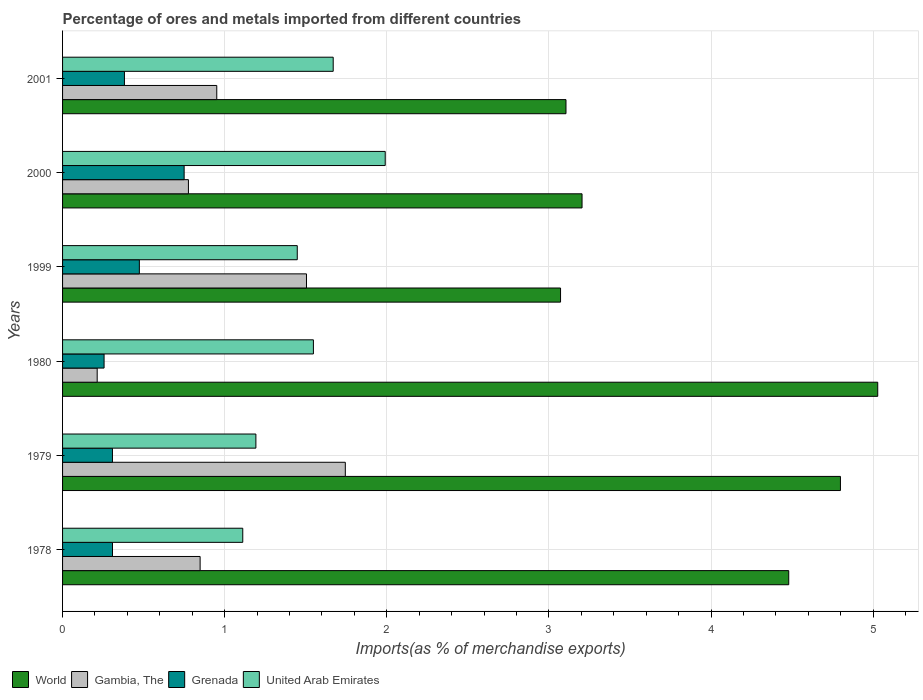How many groups of bars are there?
Provide a short and direct response. 6. Are the number of bars on each tick of the Y-axis equal?
Make the answer very short. Yes. How many bars are there on the 2nd tick from the top?
Offer a very short reply. 4. How many bars are there on the 6th tick from the bottom?
Your response must be concise. 4. What is the percentage of imports to different countries in World in 2000?
Provide a short and direct response. 3.2. Across all years, what is the maximum percentage of imports to different countries in Grenada?
Your answer should be very brief. 0.75. Across all years, what is the minimum percentage of imports to different countries in World?
Your answer should be compact. 3.07. In which year was the percentage of imports to different countries in World maximum?
Your response must be concise. 1980. What is the total percentage of imports to different countries in World in the graph?
Give a very brief answer. 23.69. What is the difference between the percentage of imports to different countries in World in 1978 and that in 2001?
Offer a very short reply. 1.37. What is the difference between the percentage of imports to different countries in World in 1978 and the percentage of imports to different countries in Grenada in 2000?
Provide a succinct answer. 3.73. What is the average percentage of imports to different countries in World per year?
Your answer should be compact. 3.95. In the year 1999, what is the difference between the percentage of imports to different countries in United Arab Emirates and percentage of imports to different countries in Grenada?
Your answer should be very brief. 0.97. What is the ratio of the percentage of imports to different countries in World in 1978 to that in 2000?
Offer a terse response. 1.4. Is the difference between the percentage of imports to different countries in United Arab Emirates in 1979 and 2000 greater than the difference between the percentage of imports to different countries in Grenada in 1979 and 2000?
Provide a succinct answer. No. What is the difference between the highest and the second highest percentage of imports to different countries in Gambia, The?
Provide a succinct answer. 0.24. What is the difference between the highest and the lowest percentage of imports to different countries in World?
Keep it short and to the point. 1.96. What does the 3rd bar from the top in 1999 represents?
Provide a short and direct response. Gambia, The. What does the 4th bar from the bottom in 2000 represents?
Provide a succinct answer. United Arab Emirates. Is it the case that in every year, the sum of the percentage of imports to different countries in Gambia, The and percentage of imports to different countries in Grenada is greater than the percentage of imports to different countries in World?
Make the answer very short. No. How many bars are there?
Give a very brief answer. 24. Are all the bars in the graph horizontal?
Ensure brevity in your answer.  Yes. How many years are there in the graph?
Keep it short and to the point. 6. Are the values on the major ticks of X-axis written in scientific E-notation?
Offer a very short reply. No. Does the graph contain grids?
Keep it short and to the point. Yes. Where does the legend appear in the graph?
Keep it short and to the point. Bottom left. How many legend labels are there?
Give a very brief answer. 4. What is the title of the graph?
Ensure brevity in your answer.  Percentage of ores and metals imported from different countries. What is the label or title of the X-axis?
Provide a succinct answer. Imports(as % of merchandise exports). What is the label or title of the Y-axis?
Make the answer very short. Years. What is the Imports(as % of merchandise exports) of World in 1978?
Your response must be concise. 4.48. What is the Imports(as % of merchandise exports) of Gambia, The in 1978?
Ensure brevity in your answer.  0.85. What is the Imports(as % of merchandise exports) of Grenada in 1978?
Give a very brief answer. 0.31. What is the Imports(as % of merchandise exports) in United Arab Emirates in 1978?
Your response must be concise. 1.11. What is the Imports(as % of merchandise exports) of World in 1979?
Your answer should be very brief. 4.8. What is the Imports(as % of merchandise exports) of Gambia, The in 1979?
Provide a succinct answer. 1.74. What is the Imports(as % of merchandise exports) of Grenada in 1979?
Make the answer very short. 0.31. What is the Imports(as % of merchandise exports) of United Arab Emirates in 1979?
Offer a terse response. 1.19. What is the Imports(as % of merchandise exports) in World in 1980?
Provide a succinct answer. 5.03. What is the Imports(as % of merchandise exports) in Gambia, The in 1980?
Your response must be concise. 0.21. What is the Imports(as % of merchandise exports) in Grenada in 1980?
Make the answer very short. 0.26. What is the Imports(as % of merchandise exports) of United Arab Emirates in 1980?
Your response must be concise. 1.55. What is the Imports(as % of merchandise exports) of World in 1999?
Give a very brief answer. 3.07. What is the Imports(as % of merchandise exports) in Gambia, The in 1999?
Make the answer very short. 1.5. What is the Imports(as % of merchandise exports) of Grenada in 1999?
Make the answer very short. 0.47. What is the Imports(as % of merchandise exports) in United Arab Emirates in 1999?
Provide a succinct answer. 1.45. What is the Imports(as % of merchandise exports) in World in 2000?
Provide a succinct answer. 3.2. What is the Imports(as % of merchandise exports) of Gambia, The in 2000?
Ensure brevity in your answer.  0.78. What is the Imports(as % of merchandise exports) of Grenada in 2000?
Provide a short and direct response. 0.75. What is the Imports(as % of merchandise exports) of United Arab Emirates in 2000?
Make the answer very short. 1.99. What is the Imports(as % of merchandise exports) of World in 2001?
Ensure brevity in your answer.  3.11. What is the Imports(as % of merchandise exports) of Gambia, The in 2001?
Your answer should be very brief. 0.95. What is the Imports(as % of merchandise exports) of Grenada in 2001?
Offer a very short reply. 0.38. What is the Imports(as % of merchandise exports) of United Arab Emirates in 2001?
Provide a succinct answer. 1.67. Across all years, what is the maximum Imports(as % of merchandise exports) of World?
Your answer should be very brief. 5.03. Across all years, what is the maximum Imports(as % of merchandise exports) of Gambia, The?
Provide a short and direct response. 1.74. Across all years, what is the maximum Imports(as % of merchandise exports) of Grenada?
Give a very brief answer. 0.75. Across all years, what is the maximum Imports(as % of merchandise exports) in United Arab Emirates?
Ensure brevity in your answer.  1.99. Across all years, what is the minimum Imports(as % of merchandise exports) in World?
Make the answer very short. 3.07. Across all years, what is the minimum Imports(as % of merchandise exports) in Gambia, The?
Ensure brevity in your answer.  0.21. Across all years, what is the minimum Imports(as % of merchandise exports) in Grenada?
Give a very brief answer. 0.26. Across all years, what is the minimum Imports(as % of merchandise exports) of United Arab Emirates?
Keep it short and to the point. 1.11. What is the total Imports(as % of merchandise exports) of World in the graph?
Offer a very short reply. 23.69. What is the total Imports(as % of merchandise exports) of Gambia, The in the graph?
Your response must be concise. 6.04. What is the total Imports(as % of merchandise exports) of Grenada in the graph?
Ensure brevity in your answer.  2.48. What is the total Imports(as % of merchandise exports) of United Arab Emirates in the graph?
Your answer should be very brief. 8.96. What is the difference between the Imports(as % of merchandise exports) in World in 1978 and that in 1979?
Offer a very short reply. -0.32. What is the difference between the Imports(as % of merchandise exports) of Gambia, The in 1978 and that in 1979?
Offer a terse response. -0.9. What is the difference between the Imports(as % of merchandise exports) in United Arab Emirates in 1978 and that in 1979?
Ensure brevity in your answer.  -0.08. What is the difference between the Imports(as % of merchandise exports) of World in 1978 and that in 1980?
Offer a terse response. -0.55. What is the difference between the Imports(as % of merchandise exports) in Gambia, The in 1978 and that in 1980?
Your response must be concise. 0.64. What is the difference between the Imports(as % of merchandise exports) of Grenada in 1978 and that in 1980?
Your answer should be very brief. 0.05. What is the difference between the Imports(as % of merchandise exports) in United Arab Emirates in 1978 and that in 1980?
Your answer should be compact. -0.44. What is the difference between the Imports(as % of merchandise exports) of World in 1978 and that in 1999?
Your answer should be very brief. 1.41. What is the difference between the Imports(as % of merchandise exports) in Gambia, The in 1978 and that in 1999?
Offer a very short reply. -0.66. What is the difference between the Imports(as % of merchandise exports) of Grenada in 1978 and that in 1999?
Your response must be concise. -0.17. What is the difference between the Imports(as % of merchandise exports) of United Arab Emirates in 1978 and that in 1999?
Offer a terse response. -0.34. What is the difference between the Imports(as % of merchandise exports) of World in 1978 and that in 2000?
Provide a succinct answer. 1.27. What is the difference between the Imports(as % of merchandise exports) of Gambia, The in 1978 and that in 2000?
Provide a succinct answer. 0.07. What is the difference between the Imports(as % of merchandise exports) in Grenada in 1978 and that in 2000?
Your response must be concise. -0.44. What is the difference between the Imports(as % of merchandise exports) of United Arab Emirates in 1978 and that in 2000?
Give a very brief answer. -0.88. What is the difference between the Imports(as % of merchandise exports) of World in 1978 and that in 2001?
Your response must be concise. 1.37. What is the difference between the Imports(as % of merchandise exports) of Gambia, The in 1978 and that in 2001?
Make the answer very short. -0.1. What is the difference between the Imports(as % of merchandise exports) of Grenada in 1978 and that in 2001?
Give a very brief answer. -0.07. What is the difference between the Imports(as % of merchandise exports) in United Arab Emirates in 1978 and that in 2001?
Your answer should be very brief. -0.56. What is the difference between the Imports(as % of merchandise exports) in World in 1979 and that in 1980?
Your answer should be very brief. -0.23. What is the difference between the Imports(as % of merchandise exports) of Gambia, The in 1979 and that in 1980?
Keep it short and to the point. 1.53. What is the difference between the Imports(as % of merchandise exports) of Grenada in 1979 and that in 1980?
Your answer should be very brief. 0.05. What is the difference between the Imports(as % of merchandise exports) of United Arab Emirates in 1979 and that in 1980?
Give a very brief answer. -0.35. What is the difference between the Imports(as % of merchandise exports) of World in 1979 and that in 1999?
Provide a short and direct response. 1.73. What is the difference between the Imports(as % of merchandise exports) of Gambia, The in 1979 and that in 1999?
Provide a succinct answer. 0.24. What is the difference between the Imports(as % of merchandise exports) in Grenada in 1979 and that in 1999?
Offer a terse response. -0.17. What is the difference between the Imports(as % of merchandise exports) of United Arab Emirates in 1979 and that in 1999?
Offer a very short reply. -0.26. What is the difference between the Imports(as % of merchandise exports) in World in 1979 and that in 2000?
Give a very brief answer. 1.59. What is the difference between the Imports(as % of merchandise exports) of Gambia, The in 1979 and that in 2000?
Provide a succinct answer. 0.97. What is the difference between the Imports(as % of merchandise exports) of Grenada in 1979 and that in 2000?
Offer a terse response. -0.44. What is the difference between the Imports(as % of merchandise exports) of United Arab Emirates in 1979 and that in 2000?
Your answer should be very brief. -0.8. What is the difference between the Imports(as % of merchandise exports) in World in 1979 and that in 2001?
Provide a short and direct response. 1.69. What is the difference between the Imports(as % of merchandise exports) of Gambia, The in 1979 and that in 2001?
Your answer should be very brief. 0.79. What is the difference between the Imports(as % of merchandise exports) of Grenada in 1979 and that in 2001?
Offer a terse response. -0.07. What is the difference between the Imports(as % of merchandise exports) in United Arab Emirates in 1979 and that in 2001?
Give a very brief answer. -0.48. What is the difference between the Imports(as % of merchandise exports) in World in 1980 and that in 1999?
Ensure brevity in your answer.  1.96. What is the difference between the Imports(as % of merchandise exports) in Gambia, The in 1980 and that in 1999?
Make the answer very short. -1.29. What is the difference between the Imports(as % of merchandise exports) in Grenada in 1980 and that in 1999?
Provide a short and direct response. -0.22. What is the difference between the Imports(as % of merchandise exports) in United Arab Emirates in 1980 and that in 1999?
Provide a succinct answer. 0.1. What is the difference between the Imports(as % of merchandise exports) in World in 1980 and that in 2000?
Your response must be concise. 1.82. What is the difference between the Imports(as % of merchandise exports) of Gambia, The in 1980 and that in 2000?
Keep it short and to the point. -0.56. What is the difference between the Imports(as % of merchandise exports) of Grenada in 1980 and that in 2000?
Keep it short and to the point. -0.49. What is the difference between the Imports(as % of merchandise exports) of United Arab Emirates in 1980 and that in 2000?
Keep it short and to the point. -0.44. What is the difference between the Imports(as % of merchandise exports) in World in 1980 and that in 2001?
Your response must be concise. 1.92. What is the difference between the Imports(as % of merchandise exports) in Gambia, The in 1980 and that in 2001?
Make the answer very short. -0.74. What is the difference between the Imports(as % of merchandise exports) in Grenada in 1980 and that in 2001?
Your response must be concise. -0.13. What is the difference between the Imports(as % of merchandise exports) of United Arab Emirates in 1980 and that in 2001?
Your answer should be compact. -0.12. What is the difference between the Imports(as % of merchandise exports) of World in 1999 and that in 2000?
Provide a succinct answer. -0.13. What is the difference between the Imports(as % of merchandise exports) in Gambia, The in 1999 and that in 2000?
Give a very brief answer. 0.73. What is the difference between the Imports(as % of merchandise exports) in Grenada in 1999 and that in 2000?
Make the answer very short. -0.28. What is the difference between the Imports(as % of merchandise exports) of United Arab Emirates in 1999 and that in 2000?
Your answer should be very brief. -0.54. What is the difference between the Imports(as % of merchandise exports) in World in 1999 and that in 2001?
Ensure brevity in your answer.  -0.03. What is the difference between the Imports(as % of merchandise exports) of Gambia, The in 1999 and that in 2001?
Provide a succinct answer. 0.55. What is the difference between the Imports(as % of merchandise exports) of Grenada in 1999 and that in 2001?
Offer a very short reply. 0.09. What is the difference between the Imports(as % of merchandise exports) in United Arab Emirates in 1999 and that in 2001?
Offer a terse response. -0.22. What is the difference between the Imports(as % of merchandise exports) in World in 2000 and that in 2001?
Your response must be concise. 0.1. What is the difference between the Imports(as % of merchandise exports) in Gambia, The in 2000 and that in 2001?
Offer a terse response. -0.17. What is the difference between the Imports(as % of merchandise exports) of Grenada in 2000 and that in 2001?
Your answer should be compact. 0.37. What is the difference between the Imports(as % of merchandise exports) in United Arab Emirates in 2000 and that in 2001?
Provide a succinct answer. 0.32. What is the difference between the Imports(as % of merchandise exports) in World in 1978 and the Imports(as % of merchandise exports) in Gambia, The in 1979?
Your answer should be very brief. 2.74. What is the difference between the Imports(as % of merchandise exports) in World in 1978 and the Imports(as % of merchandise exports) in Grenada in 1979?
Provide a succinct answer. 4.17. What is the difference between the Imports(as % of merchandise exports) of World in 1978 and the Imports(as % of merchandise exports) of United Arab Emirates in 1979?
Provide a short and direct response. 3.29. What is the difference between the Imports(as % of merchandise exports) of Gambia, The in 1978 and the Imports(as % of merchandise exports) of Grenada in 1979?
Make the answer very short. 0.54. What is the difference between the Imports(as % of merchandise exports) of Gambia, The in 1978 and the Imports(as % of merchandise exports) of United Arab Emirates in 1979?
Give a very brief answer. -0.34. What is the difference between the Imports(as % of merchandise exports) in Grenada in 1978 and the Imports(as % of merchandise exports) in United Arab Emirates in 1979?
Provide a succinct answer. -0.88. What is the difference between the Imports(as % of merchandise exports) of World in 1978 and the Imports(as % of merchandise exports) of Gambia, The in 1980?
Make the answer very short. 4.27. What is the difference between the Imports(as % of merchandise exports) of World in 1978 and the Imports(as % of merchandise exports) of Grenada in 1980?
Your response must be concise. 4.22. What is the difference between the Imports(as % of merchandise exports) in World in 1978 and the Imports(as % of merchandise exports) in United Arab Emirates in 1980?
Your response must be concise. 2.93. What is the difference between the Imports(as % of merchandise exports) in Gambia, The in 1978 and the Imports(as % of merchandise exports) in Grenada in 1980?
Your response must be concise. 0.59. What is the difference between the Imports(as % of merchandise exports) in Gambia, The in 1978 and the Imports(as % of merchandise exports) in United Arab Emirates in 1980?
Make the answer very short. -0.7. What is the difference between the Imports(as % of merchandise exports) of Grenada in 1978 and the Imports(as % of merchandise exports) of United Arab Emirates in 1980?
Your answer should be very brief. -1.24. What is the difference between the Imports(as % of merchandise exports) of World in 1978 and the Imports(as % of merchandise exports) of Gambia, The in 1999?
Provide a succinct answer. 2.97. What is the difference between the Imports(as % of merchandise exports) in World in 1978 and the Imports(as % of merchandise exports) in Grenada in 1999?
Ensure brevity in your answer.  4.01. What is the difference between the Imports(as % of merchandise exports) in World in 1978 and the Imports(as % of merchandise exports) in United Arab Emirates in 1999?
Give a very brief answer. 3.03. What is the difference between the Imports(as % of merchandise exports) of Gambia, The in 1978 and the Imports(as % of merchandise exports) of Grenada in 1999?
Your response must be concise. 0.37. What is the difference between the Imports(as % of merchandise exports) in Gambia, The in 1978 and the Imports(as % of merchandise exports) in United Arab Emirates in 1999?
Provide a succinct answer. -0.6. What is the difference between the Imports(as % of merchandise exports) in Grenada in 1978 and the Imports(as % of merchandise exports) in United Arab Emirates in 1999?
Make the answer very short. -1.14. What is the difference between the Imports(as % of merchandise exports) of World in 1978 and the Imports(as % of merchandise exports) of Gambia, The in 2000?
Make the answer very short. 3.7. What is the difference between the Imports(as % of merchandise exports) of World in 1978 and the Imports(as % of merchandise exports) of Grenada in 2000?
Keep it short and to the point. 3.73. What is the difference between the Imports(as % of merchandise exports) of World in 1978 and the Imports(as % of merchandise exports) of United Arab Emirates in 2000?
Give a very brief answer. 2.49. What is the difference between the Imports(as % of merchandise exports) of Gambia, The in 1978 and the Imports(as % of merchandise exports) of Grenada in 2000?
Your answer should be very brief. 0.1. What is the difference between the Imports(as % of merchandise exports) of Gambia, The in 1978 and the Imports(as % of merchandise exports) of United Arab Emirates in 2000?
Keep it short and to the point. -1.14. What is the difference between the Imports(as % of merchandise exports) in Grenada in 1978 and the Imports(as % of merchandise exports) in United Arab Emirates in 2000?
Provide a short and direct response. -1.68. What is the difference between the Imports(as % of merchandise exports) in World in 1978 and the Imports(as % of merchandise exports) in Gambia, The in 2001?
Provide a short and direct response. 3.53. What is the difference between the Imports(as % of merchandise exports) in World in 1978 and the Imports(as % of merchandise exports) in Grenada in 2001?
Offer a terse response. 4.1. What is the difference between the Imports(as % of merchandise exports) of World in 1978 and the Imports(as % of merchandise exports) of United Arab Emirates in 2001?
Keep it short and to the point. 2.81. What is the difference between the Imports(as % of merchandise exports) in Gambia, The in 1978 and the Imports(as % of merchandise exports) in Grenada in 2001?
Your response must be concise. 0.47. What is the difference between the Imports(as % of merchandise exports) in Gambia, The in 1978 and the Imports(as % of merchandise exports) in United Arab Emirates in 2001?
Ensure brevity in your answer.  -0.82. What is the difference between the Imports(as % of merchandise exports) of Grenada in 1978 and the Imports(as % of merchandise exports) of United Arab Emirates in 2001?
Your answer should be very brief. -1.36. What is the difference between the Imports(as % of merchandise exports) in World in 1979 and the Imports(as % of merchandise exports) in Gambia, The in 1980?
Keep it short and to the point. 4.58. What is the difference between the Imports(as % of merchandise exports) in World in 1979 and the Imports(as % of merchandise exports) in Grenada in 1980?
Provide a succinct answer. 4.54. What is the difference between the Imports(as % of merchandise exports) of World in 1979 and the Imports(as % of merchandise exports) of United Arab Emirates in 1980?
Make the answer very short. 3.25. What is the difference between the Imports(as % of merchandise exports) of Gambia, The in 1979 and the Imports(as % of merchandise exports) of Grenada in 1980?
Your answer should be compact. 1.49. What is the difference between the Imports(as % of merchandise exports) in Gambia, The in 1979 and the Imports(as % of merchandise exports) in United Arab Emirates in 1980?
Provide a succinct answer. 0.2. What is the difference between the Imports(as % of merchandise exports) of Grenada in 1979 and the Imports(as % of merchandise exports) of United Arab Emirates in 1980?
Your answer should be very brief. -1.24. What is the difference between the Imports(as % of merchandise exports) of World in 1979 and the Imports(as % of merchandise exports) of Gambia, The in 1999?
Keep it short and to the point. 3.29. What is the difference between the Imports(as % of merchandise exports) in World in 1979 and the Imports(as % of merchandise exports) in Grenada in 1999?
Ensure brevity in your answer.  4.32. What is the difference between the Imports(as % of merchandise exports) of World in 1979 and the Imports(as % of merchandise exports) of United Arab Emirates in 1999?
Provide a short and direct response. 3.35. What is the difference between the Imports(as % of merchandise exports) of Gambia, The in 1979 and the Imports(as % of merchandise exports) of Grenada in 1999?
Give a very brief answer. 1.27. What is the difference between the Imports(as % of merchandise exports) of Gambia, The in 1979 and the Imports(as % of merchandise exports) of United Arab Emirates in 1999?
Offer a terse response. 0.3. What is the difference between the Imports(as % of merchandise exports) of Grenada in 1979 and the Imports(as % of merchandise exports) of United Arab Emirates in 1999?
Offer a very short reply. -1.14. What is the difference between the Imports(as % of merchandise exports) of World in 1979 and the Imports(as % of merchandise exports) of Gambia, The in 2000?
Your response must be concise. 4.02. What is the difference between the Imports(as % of merchandise exports) of World in 1979 and the Imports(as % of merchandise exports) of Grenada in 2000?
Ensure brevity in your answer.  4.05. What is the difference between the Imports(as % of merchandise exports) of World in 1979 and the Imports(as % of merchandise exports) of United Arab Emirates in 2000?
Offer a very short reply. 2.81. What is the difference between the Imports(as % of merchandise exports) in Gambia, The in 1979 and the Imports(as % of merchandise exports) in Grenada in 2000?
Provide a succinct answer. 0.99. What is the difference between the Imports(as % of merchandise exports) in Gambia, The in 1979 and the Imports(as % of merchandise exports) in United Arab Emirates in 2000?
Make the answer very short. -0.25. What is the difference between the Imports(as % of merchandise exports) in Grenada in 1979 and the Imports(as % of merchandise exports) in United Arab Emirates in 2000?
Provide a short and direct response. -1.68. What is the difference between the Imports(as % of merchandise exports) of World in 1979 and the Imports(as % of merchandise exports) of Gambia, The in 2001?
Ensure brevity in your answer.  3.85. What is the difference between the Imports(as % of merchandise exports) in World in 1979 and the Imports(as % of merchandise exports) in Grenada in 2001?
Keep it short and to the point. 4.42. What is the difference between the Imports(as % of merchandise exports) of World in 1979 and the Imports(as % of merchandise exports) of United Arab Emirates in 2001?
Your answer should be very brief. 3.13. What is the difference between the Imports(as % of merchandise exports) in Gambia, The in 1979 and the Imports(as % of merchandise exports) in Grenada in 2001?
Ensure brevity in your answer.  1.36. What is the difference between the Imports(as % of merchandise exports) in Gambia, The in 1979 and the Imports(as % of merchandise exports) in United Arab Emirates in 2001?
Offer a very short reply. 0.07. What is the difference between the Imports(as % of merchandise exports) in Grenada in 1979 and the Imports(as % of merchandise exports) in United Arab Emirates in 2001?
Make the answer very short. -1.36. What is the difference between the Imports(as % of merchandise exports) of World in 1980 and the Imports(as % of merchandise exports) of Gambia, The in 1999?
Provide a succinct answer. 3.52. What is the difference between the Imports(as % of merchandise exports) in World in 1980 and the Imports(as % of merchandise exports) in Grenada in 1999?
Provide a succinct answer. 4.55. What is the difference between the Imports(as % of merchandise exports) of World in 1980 and the Imports(as % of merchandise exports) of United Arab Emirates in 1999?
Your response must be concise. 3.58. What is the difference between the Imports(as % of merchandise exports) in Gambia, The in 1980 and the Imports(as % of merchandise exports) in Grenada in 1999?
Make the answer very short. -0.26. What is the difference between the Imports(as % of merchandise exports) of Gambia, The in 1980 and the Imports(as % of merchandise exports) of United Arab Emirates in 1999?
Give a very brief answer. -1.23. What is the difference between the Imports(as % of merchandise exports) in Grenada in 1980 and the Imports(as % of merchandise exports) in United Arab Emirates in 1999?
Ensure brevity in your answer.  -1.19. What is the difference between the Imports(as % of merchandise exports) of World in 1980 and the Imports(as % of merchandise exports) of Gambia, The in 2000?
Your answer should be very brief. 4.25. What is the difference between the Imports(as % of merchandise exports) of World in 1980 and the Imports(as % of merchandise exports) of Grenada in 2000?
Ensure brevity in your answer.  4.28. What is the difference between the Imports(as % of merchandise exports) in World in 1980 and the Imports(as % of merchandise exports) in United Arab Emirates in 2000?
Your answer should be very brief. 3.04. What is the difference between the Imports(as % of merchandise exports) in Gambia, The in 1980 and the Imports(as % of merchandise exports) in Grenada in 2000?
Give a very brief answer. -0.54. What is the difference between the Imports(as % of merchandise exports) of Gambia, The in 1980 and the Imports(as % of merchandise exports) of United Arab Emirates in 2000?
Offer a very short reply. -1.78. What is the difference between the Imports(as % of merchandise exports) in Grenada in 1980 and the Imports(as % of merchandise exports) in United Arab Emirates in 2000?
Your answer should be very brief. -1.73. What is the difference between the Imports(as % of merchandise exports) in World in 1980 and the Imports(as % of merchandise exports) in Gambia, The in 2001?
Make the answer very short. 4.08. What is the difference between the Imports(as % of merchandise exports) of World in 1980 and the Imports(as % of merchandise exports) of Grenada in 2001?
Keep it short and to the point. 4.65. What is the difference between the Imports(as % of merchandise exports) of World in 1980 and the Imports(as % of merchandise exports) of United Arab Emirates in 2001?
Your answer should be compact. 3.36. What is the difference between the Imports(as % of merchandise exports) of Gambia, The in 1980 and the Imports(as % of merchandise exports) of Grenada in 2001?
Keep it short and to the point. -0.17. What is the difference between the Imports(as % of merchandise exports) of Gambia, The in 1980 and the Imports(as % of merchandise exports) of United Arab Emirates in 2001?
Offer a very short reply. -1.46. What is the difference between the Imports(as % of merchandise exports) of Grenada in 1980 and the Imports(as % of merchandise exports) of United Arab Emirates in 2001?
Offer a terse response. -1.41. What is the difference between the Imports(as % of merchandise exports) of World in 1999 and the Imports(as % of merchandise exports) of Gambia, The in 2000?
Provide a succinct answer. 2.3. What is the difference between the Imports(as % of merchandise exports) in World in 1999 and the Imports(as % of merchandise exports) in Grenada in 2000?
Make the answer very short. 2.32. What is the difference between the Imports(as % of merchandise exports) of World in 1999 and the Imports(as % of merchandise exports) of United Arab Emirates in 2000?
Make the answer very short. 1.08. What is the difference between the Imports(as % of merchandise exports) of Gambia, The in 1999 and the Imports(as % of merchandise exports) of Grenada in 2000?
Give a very brief answer. 0.75. What is the difference between the Imports(as % of merchandise exports) of Gambia, The in 1999 and the Imports(as % of merchandise exports) of United Arab Emirates in 2000?
Offer a very short reply. -0.49. What is the difference between the Imports(as % of merchandise exports) in Grenada in 1999 and the Imports(as % of merchandise exports) in United Arab Emirates in 2000?
Make the answer very short. -1.52. What is the difference between the Imports(as % of merchandise exports) of World in 1999 and the Imports(as % of merchandise exports) of Gambia, The in 2001?
Offer a terse response. 2.12. What is the difference between the Imports(as % of merchandise exports) of World in 1999 and the Imports(as % of merchandise exports) of Grenada in 2001?
Your response must be concise. 2.69. What is the difference between the Imports(as % of merchandise exports) of World in 1999 and the Imports(as % of merchandise exports) of United Arab Emirates in 2001?
Your answer should be compact. 1.4. What is the difference between the Imports(as % of merchandise exports) of Gambia, The in 1999 and the Imports(as % of merchandise exports) of Grenada in 2001?
Keep it short and to the point. 1.12. What is the difference between the Imports(as % of merchandise exports) in Gambia, The in 1999 and the Imports(as % of merchandise exports) in United Arab Emirates in 2001?
Offer a very short reply. -0.16. What is the difference between the Imports(as % of merchandise exports) of Grenada in 1999 and the Imports(as % of merchandise exports) of United Arab Emirates in 2001?
Provide a succinct answer. -1.2. What is the difference between the Imports(as % of merchandise exports) of World in 2000 and the Imports(as % of merchandise exports) of Gambia, The in 2001?
Offer a very short reply. 2.25. What is the difference between the Imports(as % of merchandise exports) in World in 2000 and the Imports(as % of merchandise exports) in Grenada in 2001?
Offer a very short reply. 2.82. What is the difference between the Imports(as % of merchandise exports) of World in 2000 and the Imports(as % of merchandise exports) of United Arab Emirates in 2001?
Your answer should be compact. 1.53. What is the difference between the Imports(as % of merchandise exports) of Gambia, The in 2000 and the Imports(as % of merchandise exports) of Grenada in 2001?
Provide a short and direct response. 0.39. What is the difference between the Imports(as % of merchandise exports) in Gambia, The in 2000 and the Imports(as % of merchandise exports) in United Arab Emirates in 2001?
Make the answer very short. -0.89. What is the difference between the Imports(as % of merchandise exports) of Grenada in 2000 and the Imports(as % of merchandise exports) of United Arab Emirates in 2001?
Give a very brief answer. -0.92. What is the average Imports(as % of merchandise exports) of World per year?
Your answer should be compact. 3.95. What is the average Imports(as % of merchandise exports) in Gambia, The per year?
Offer a terse response. 1.01. What is the average Imports(as % of merchandise exports) in Grenada per year?
Keep it short and to the point. 0.41. What is the average Imports(as % of merchandise exports) in United Arab Emirates per year?
Your answer should be very brief. 1.49. In the year 1978, what is the difference between the Imports(as % of merchandise exports) in World and Imports(as % of merchandise exports) in Gambia, The?
Keep it short and to the point. 3.63. In the year 1978, what is the difference between the Imports(as % of merchandise exports) in World and Imports(as % of merchandise exports) in Grenada?
Offer a terse response. 4.17. In the year 1978, what is the difference between the Imports(as % of merchandise exports) of World and Imports(as % of merchandise exports) of United Arab Emirates?
Offer a very short reply. 3.37. In the year 1978, what is the difference between the Imports(as % of merchandise exports) of Gambia, The and Imports(as % of merchandise exports) of Grenada?
Provide a short and direct response. 0.54. In the year 1978, what is the difference between the Imports(as % of merchandise exports) of Gambia, The and Imports(as % of merchandise exports) of United Arab Emirates?
Keep it short and to the point. -0.26. In the year 1978, what is the difference between the Imports(as % of merchandise exports) in Grenada and Imports(as % of merchandise exports) in United Arab Emirates?
Make the answer very short. -0.8. In the year 1979, what is the difference between the Imports(as % of merchandise exports) in World and Imports(as % of merchandise exports) in Gambia, The?
Keep it short and to the point. 3.05. In the year 1979, what is the difference between the Imports(as % of merchandise exports) of World and Imports(as % of merchandise exports) of Grenada?
Give a very brief answer. 4.49. In the year 1979, what is the difference between the Imports(as % of merchandise exports) of World and Imports(as % of merchandise exports) of United Arab Emirates?
Give a very brief answer. 3.61. In the year 1979, what is the difference between the Imports(as % of merchandise exports) in Gambia, The and Imports(as % of merchandise exports) in Grenada?
Offer a very short reply. 1.44. In the year 1979, what is the difference between the Imports(as % of merchandise exports) in Gambia, The and Imports(as % of merchandise exports) in United Arab Emirates?
Ensure brevity in your answer.  0.55. In the year 1979, what is the difference between the Imports(as % of merchandise exports) of Grenada and Imports(as % of merchandise exports) of United Arab Emirates?
Your answer should be very brief. -0.88. In the year 1980, what is the difference between the Imports(as % of merchandise exports) in World and Imports(as % of merchandise exports) in Gambia, The?
Make the answer very short. 4.82. In the year 1980, what is the difference between the Imports(as % of merchandise exports) of World and Imports(as % of merchandise exports) of Grenada?
Provide a short and direct response. 4.77. In the year 1980, what is the difference between the Imports(as % of merchandise exports) of World and Imports(as % of merchandise exports) of United Arab Emirates?
Provide a succinct answer. 3.48. In the year 1980, what is the difference between the Imports(as % of merchandise exports) of Gambia, The and Imports(as % of merchandise exports) of Grenada?
Provide a short and direct response. -0.04. In the year 1980, what is the difference between the Imports(as % of merchandise exports) in Gambia, The and Imports(as % of merchandise exports) in United Arab Emirates?
Your answer should be compact. -1.33. In the year 1980, what is the difference between the Imports(as % of merchandise exports) in Grenada and Imports(as % of merchandise exports) in United Arab Emirates?
Keep it short and to the point. -1.29. In the year 1999, what is the difference between the Imports(as % of merchandise exports) of World and Imports(as % of merchandise exports) of Gambia, The?
Keep it short and to the point. 1.57. In the year 1999, what is the difference between the Imports(as % of merchandise exports) of World and Imports(as % of merchandise exports) of Grenada?
Make the answer very short. 2.6. In the year 1999, what is the difference between the Imports(as % of merchandise exports) in World and Imports(as % of merchandise exports) in United Arab Emirates?
Your response must be concise. 1.62. In the year 1999, what is the difference between the Imports(as % of merchandise exports) of Gambia, The and Imports(as % of merchandise exports) of Grenada?
Your answer should be compact. 1.03. In the year 1999, what is the difference between the Imports(as % of merchandise exports) of Gambia, The and Imports(as % of merchandise exports) of United Arab Emirates?
Your answer should be very brief. 0.06. In the year 1999, what is the difference between the Imports(as % of merchandise exports) in Grenada and Imports(as % of merchandise exports) in United Arab Emirates?
Offer a terse response. -0.97. In the year 2000, what is the difference between the Imports(as % of merchandise exports) of World and Imports(as % of merchandise exports) of Gambia, The?
Your answer should be very brief. 2.43. In the year 2000, what is the difference between the Imports(as % of merchandise exports) in World and Imports(as % of merchandise exports) in Grenada?
Provide a short and direct response. 2.45. In the year 2000, what is the difference between the Imports(as % of merchandise exports) in World and Imports(as % of merchandise exports) in United Arab Emirates?
Make the answer very short. 1.21. In the year 2000, what is the difference between the Imports(as % of merchandise exports) in Gambia, The and Imports(as % of merchandise exports) in Grenada?
Make the answer very short. 0.03. In the year 2000, what is the difference between the Imports(as % of merchandise exports) of Gambia, The and Imports(as % of merchandise exports) of United Arab Emirates?
Your response must be concise. -1.21. In the year 2000, what is the difference between the Imports(as % of merchandise exports) in Grenada and Imports(as % of merchandise exports) in United Arab Emirates?
Give a very brief answer. -1.24. In the year 2001, what is the difference between the Imports(as % of merchandise exports) in World and Imports(as % of merchandise exports) in Gambia, The?
Ensure brevity in your answer.  2.15. In the year 2001, what is the difference between the Imports(as % of merchandise exports) of World and Imports(as % of merchandise exports) of Grenada?
Your response must be concise. 2.72. In the year 2001, what is the difference between the Imports(as % of merchandise exports) in World and Imports(as % of merchandise exports) in United Arab Emirates?
Ensure brevity in your answer.  1.44. In the year 2001, what is the difference between the Imports(as % of merchandise exports) of Gambia, The and Imports(as % of merchandise exports) of Grenada?
Your answer should be compact. 0.57. In the year 2001, what is the difference between the Imports(as % of merchandise exports) of Gambia, The and Imports(as % of merchandise exports) of United Arab Emirates?
Keep it short and to the point. -0.72. In the year 2001, what is the difference between the Imports(as % of merchandise exports) of Grenada and Imports(as % of merchandise exports) of United Arab Emirates?
Keep it short and to the point. -1.29. What is the ratio of the Imports(as % of merchandise exports) in World in 1978 to that in 1979?
Your answer should be very brief. 0.93. What is the ratio of the Imports(as % of merchandise exports) of Gambia, The in 1978 to that in 1979?
Provide a succinct answer. 0.49. What is the ratio of the Imports(as % of merchandise exports) in United Arab Emirates in 1978 to that in 1979?
Your answer should be compact. 0.93. What is the ratio of the Imports(as % of merchandise exports) of World in 1978 to that in 1980?
Your answer should be very brief. 0.89. What is the ratio of the Imports(as % of merchandise exports) in Gambia, The in 1978 to that in 1980?
Ensure brevity in your answer.  3.97. What is the ratio of the Imports(as % of merchandise exports) of Grenada in 1978 to that in 1980?
Your answer should be compact. 1.2. What is the ratio of the Imports(as % of merchandise exports) in United Arab Emirates in 1978 to that in 1980?
Offer a very short reply. 0.72. What is the ratio of the Imports(as % of merchandise exports) in World in 1978 to that in 1999?
Make the answer very short. 1.46. What is the ratio of the Imports(as % of merchandise exports) of Gambia, The in 1978 to that in 1999?
Provide a succinct answer. 0.56. What is the ratio of the Imports(as % of merchandise exports) of Grenada in 1978 to that in 1999?
Your response must be concise. 0.65. What is the ratio of the Imports(as % of merchandise exports) in United Arab Emirates in 1978 to that in 1999?
Offer a very short reply. 0.77. What is the ratio of the Imports(as % of merchandise exports) of World in 1978 to that in 2000?
Your answer should be very brief. 1.4. What is the ratio of the Imports(as % of merchandise exports) in Gambia, The in 1978 to that in 2000?
Provide a succinct answer. 1.09. What is the ratio of the Imports(as % of merchandise exports) of Grenada in 1978 to that in 2000?
Your answer should be very brief. 0.41. What is the ratio of the Imports(as % of merchandise exports) of United Arab Emirates in 1978 to that in 2000?
Give a very brief answer. 0.56. What is the ratio of the Imports(as % of merchandise exports) of World in 1978 to that in 2001?
Your response must be concise. 1.44. What is the ratio of the Imports(as % of merchandise exports) of Gambia, The in 1978 to that in 2001?
Provide a short and direct response. 0.89. What is the ratio of the Imports(as % of merchandise exports) in Grenada in 1978 to that in 2001?
Give a very brief answer. 0.81. What is the ratio of the Imports(as % of merchandise exports) of United Arab Emirates in 1978 to that in 2001?
Ensure brevity in your answer.  0.67. What is the ratio of the Imports(as % of merchandise exports) of World in 1979 to that in 1980?
Give a very brief answer. 0.95. What is the ratio of the Imports(as % of merchandise exports) in Gambia, The in 1979 to that in 1980?
Your answer should be very brief. 8.17. What is the ratio of the Imports(as % of merchandise exports) in Grenada in 1979 to that in 1980?
Offer a terse response. 1.2. What is the ratio of the Imports(as % of merchandise exports) of United Arab Emirates in 1979 to that in 1980?
Make the answer very short. 0.77. What is the ratio of the Imports(as % of merchandise exports) of World in 1979 to that in 1999?
Your answer should be compact. 1.56. What is the ratio of the Imports(as % of merchandise exports) of Gambia, The in 1979 to that in 1999?
Your answer should be compact. 1.16. What is the ratio of the Imports(as % of merchandise exports) of Grenada in 1979 to that in 1999?
Your answer should be compact. 0.65. What is the ratio of the Imports(as % of merchandise exports) in United Arab Emirates in 1979 to that in 1999?
Your answer should be compact. 0.82. What is the ratio of the Imports(as % of merchandise exports) in World in 1979 to that in 2000?
Offer a very short reply. 1.5. What is the ratio of the Imports(as % of merchandise exports) of Gambia, The in 1979 to that in 2000?
Provide a short and direct response. 2.25. What is the ratio of the Imports(as % of merchandise exports) in Grenada in 1979 to that in 2000?
Your answer should be compact. 0.41. What is the ratio of the Imports(as % of merchandise exports) in United Arab Emirates in 1979 to that in 2000?
Your answer should be compact. 0.6. What is the ratio of the Imports(as % of merchandise exports) in World in 1979 to that in 2001?
Give a very brief answer. 1.55. What is the ratio of the Imports(as % of merchandise exports) in Gambia, The in 1979 to that in 2001?
Ensure brevity in your answer.  1.83. What is the ratio of the Imports(as % of merchandise exports) of Grenada in 1979 to that in 2001?
Ensure brevity in your answer.  0.81. What is the ratio of the Imports(as % of merchandise exports) in World in 1980 to that in 1999?
Give a very brief answer. 1.64. What is the ratio of the Imports(as % of merchandise exports) of Gambia, The in 1980 to that in 1999?
Make the answer very short. 0.14. What is the ratio of the Imports(as % of merchandise exports) in Grenada in 1980 to that in 1999?
Your answer should be compact. 0.54. What is the ratio of the Imports(as % of merchandise exports) in United Arab Emirates in 1980 to that in 1999?
Provide a succinct answer. 1.07. What is the ratio of the Imports(as % of merchandise exports) of World in 1980 to that in 2000?
Your answer should be very brief. 1.57. What is the ratio of the Imports(as % of merchandise exports) in Gambia, The in 1980 to that in 2000?
Your response must be concise. 0.28. What is the ratio of the Imports(as % of merchandise exports) in Grenada in 1980 to that in 2000?
Your answer should be compact. 0.34. What is the ratio of the Imports(as % of merchandise exports) in United Arab Emirates in 1980 to that in 2000?
Ensure brevity in your answer.  0.78. What is the ratio of the Imports(as % of merchandise exports) of World in 1980 to that in 2001?
Offer a terse response. 1.62. What is the ratio of the Imports(as % of merchandise exports) of Gambia, The in 1980 to that in 2001?
Your answer should be very brief. 0.22. What is the ratio of the Imports(as % of merchandise exports) in Grenada in 1980 to that in 2001?
Your response must be concise. 0.67. What is the ratio of the Imports(as % of merchandise exports) in United Arab Emirates in 1980 to that in 2001?
Your answer should be very brief. 0.93. What is the ratio of the Imports(as % of merchandise exports) in World in 1999 to that in 2000?
Give a very brief answer. 0.96. What is the ratio of the Imports(as % of merchandise exports) of Gambia, The in 1999 to that in 2000?
Make the answer very short. 1.94. What is the ratio of the Imports(as % of merchandise exports) in Grenada in 1999 to that in 2000?
Offer a very short reply. 0.63. What is the ratio of the Imports(as % of merchandise exports) in United Arab Emirates in 1999 to that in 2000?
Your answer should be very brief. 0.73. What is the ratio of the Imports(as % of merchandise exports) in World in 1999 to that in 2001?
Ensure brevity in your answer.  0.99. What is the ratio of the Imports(as % of merchandise exports) in Gambia, The in 1999 to that in 2001?
Provide a succinct answer. 1.58. What is the ratio of the Imports(as % of merchandise exports) of Grenada in 1999 to that in 2001?
Offer a very short reply. 1.24. What is the ratio of the Imports(as % of merchandise exports) of United Arab Emirates in 1999 to that in 2001?
Make the answer very short. 0.87. What is the ratio of the Imports(as % of merchandise exports) in World in 2000 to that in 2001?
Offer a very short reply. 1.03. What is the ratio of the Imports(as % of merchandise exports) in Gambia, The in 2000 to that in 2001?
Your response must be concise. 0.82. What is the ratio of the Imports(as % of merchandise exports) in Grenada in 2000 to that in 2001?
Your response must be concise. 1.96. What is the ratio of the Imports(as % of merchandise exports) of United Arab Emirates in 2000 to that in 2001?
Make the answer very short. 1.19. What is the difference between the highest and the second highest Imports(as % of merchandise exports) of World?
Offer a terse response. 0.23. What is the difference between the highest and the second highest Imports(as % of merchandise exports) of Gambia, The?
Offer a very short reply. 0.24. What is the difference between the highest and the second highest Imports(as % of merchandise exports) of Grenada?
Ensure brevity in your answer.  0.28. What is the difference between the highest and the second highest Imports(as % of merchandise exports) in United Arab Emirates?
Make the answer very short. 0.32. What is the difference between the highest and the lowest Imports(as % of merchandise exports) of World?
Provide a succinct answer. 1.96. What is the difference between the highest and the lowest Imports(as % of merchandise exports) in Gambia, The?
Make the answer very short. 1.53. What is the difference between the highest and the lowest Imports(as % of merchandise exports) in Grenada?
Your response must be concise. 0.49. What is the difference between the highest and the lowest Imports(as % of merchandise exports) in United Arab Emirates?
Your answer should be compact. 0.88. 